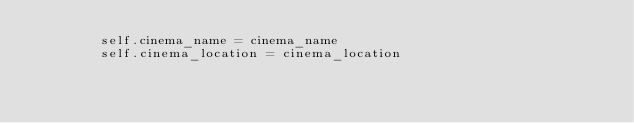Convert code to text. <code><loc_0><loc_0><loc_500><loc_500><_Python_>        self.cinema_name = cinema_name
        self.cinema_location = cinema_location</code> 